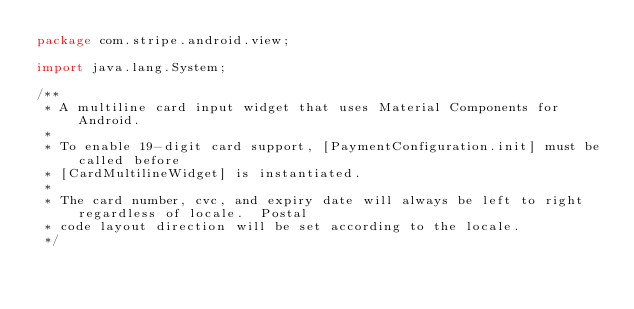<code> <loc_0><loc_0><loc_500><loc_500><_Java_>package com.stripe.android.view;

import java.lang.System;

/**
 * A multiline card input widget that uses Material Components for Android.
 *
 * To enable 19-digit card support, [PaymentConfiguration.init] must be called before
 * [CardMultilineWidget] is instantiated.
 *
 * The card number, cvc, and expiry date will always be left to right regardless of locale.  Postal
 * code layout direction will be set according to the locale.
 */</code> 